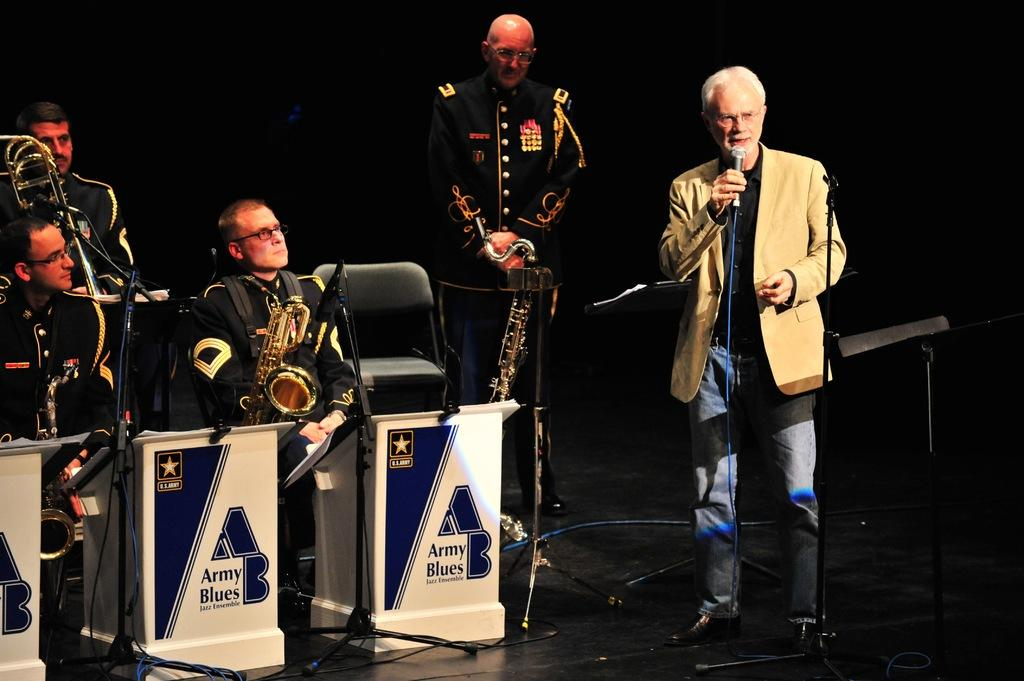How many people are present in the image? There are five people in the image. What are the positions of the people in the image? Three of the people are sitting on chairs, and two of the people are standing. What objects can be seen in the image related to music? There are microphones (mics), stands, and saxophones in the image. Are there any wires visible in the image? Yes, there are wires in the image. What is the color of the background in the image? The background of the image is dark. Can you tell me how many owls are sitting on the person's shoulder in the image? There are no owls present in the image; it features people, music-related objects, and wires. Is there a jail visible in the image? There is no jail present in the image. 